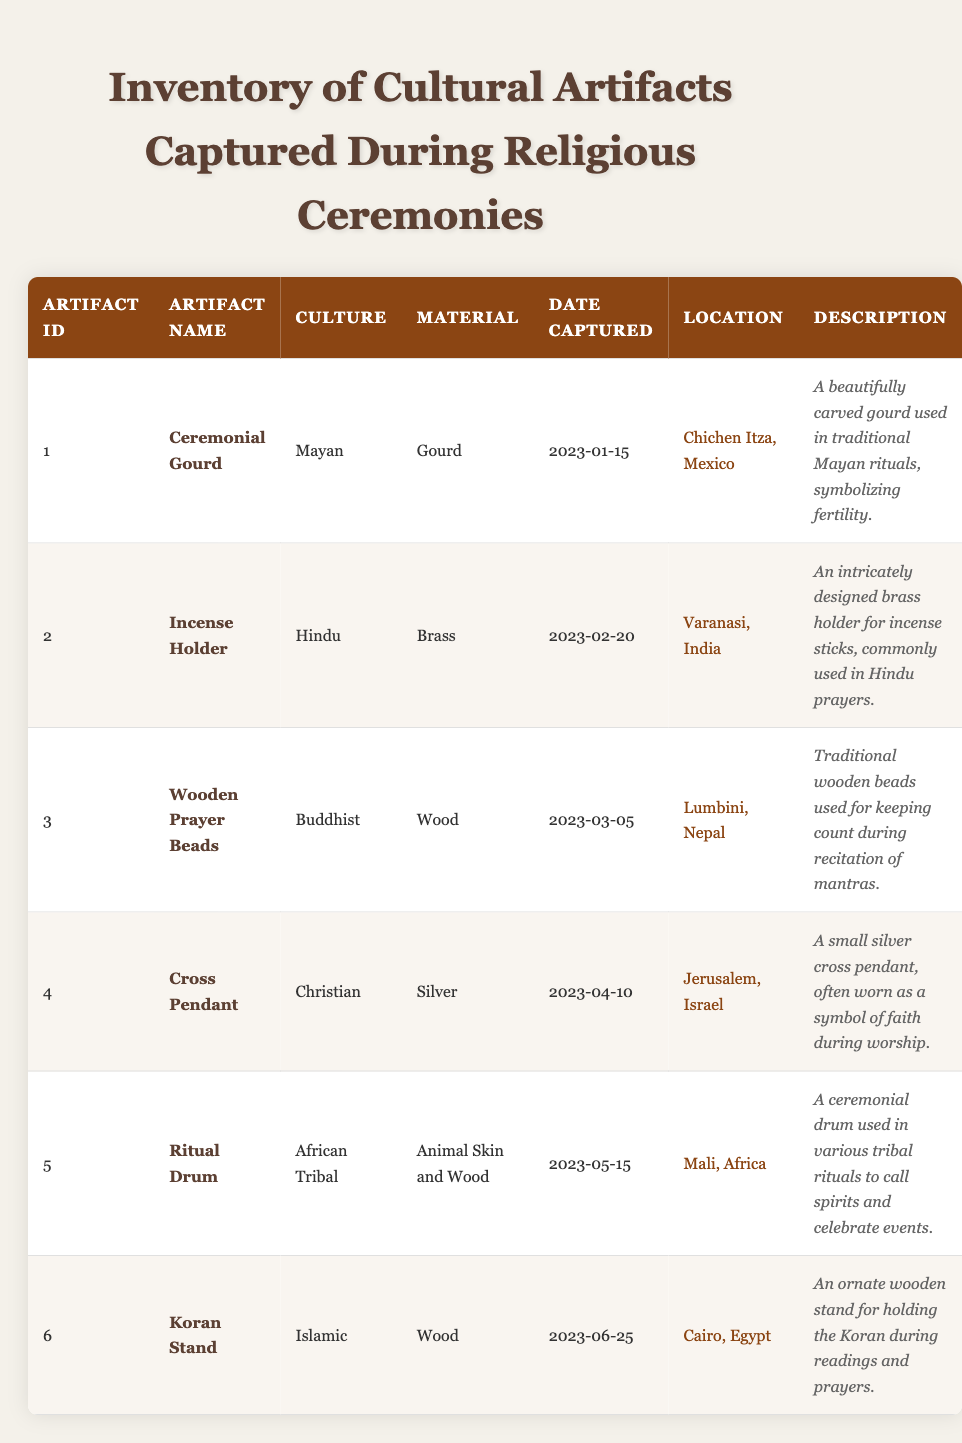What is the material of the Cross Pendant? The material of the Cross Pendant can be found in the "Material" column of the row corresponding to this artifact, which indicates it is made of Silver.
Answer: Silver Which artifact was captured in Varanasi, India? Looking at the "Location" column, the row that lists Varanasi, India shows that the "Incense Holder" was captured there.
Answer: Incense Holder How many artifacts are made of wood? By inspecting the "Material" column, we can identify the artifacts made of wood. The Wooden Prayer Beads and Koran Stand are made of wood, totaling two artifacts.
Answer: 2 Is the Ceremonial Gourd used in Mayan rituals? The description of the Ceremonial Gourd states that it is used in traditional Mayan rituals, confirming that it is indeed used in this context.
Answer: Yes Which artifact captured in Jerusalem is made of silver? Checking the relevant rows, we find that the artifact captured in Jerusalem is the Cross Pendant, which is indeed made of silver.
Answer: Cross Pendant What is the average date of capture for all artifacts? We list the capture dates as follows: January 15, February 20, March 5, April 10, May 15, and June 25. Calculating the average requires converting these dates into a numerical format. The average date is roughly in early May.
Answer: Early May Which culture has the most artifacts represented in the table? Counting the unique entries for each culture reveals: Mayan, Hindu, Buddhist, Christian, African Tribal, and Islamic — each represented only once, showing no culture has multiple artifacts.
Answer: No culture has more What material is used for the Ritual Drum? The table specifies that the Ritual Drum is made from Animal Skin and Wood as per the entry in the "Material" column.
Answer: Animal Skin and Wood 